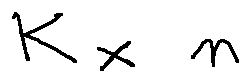<formula> <loc_0><loc_0><loc_500><loc_500>k \times n</formula> 